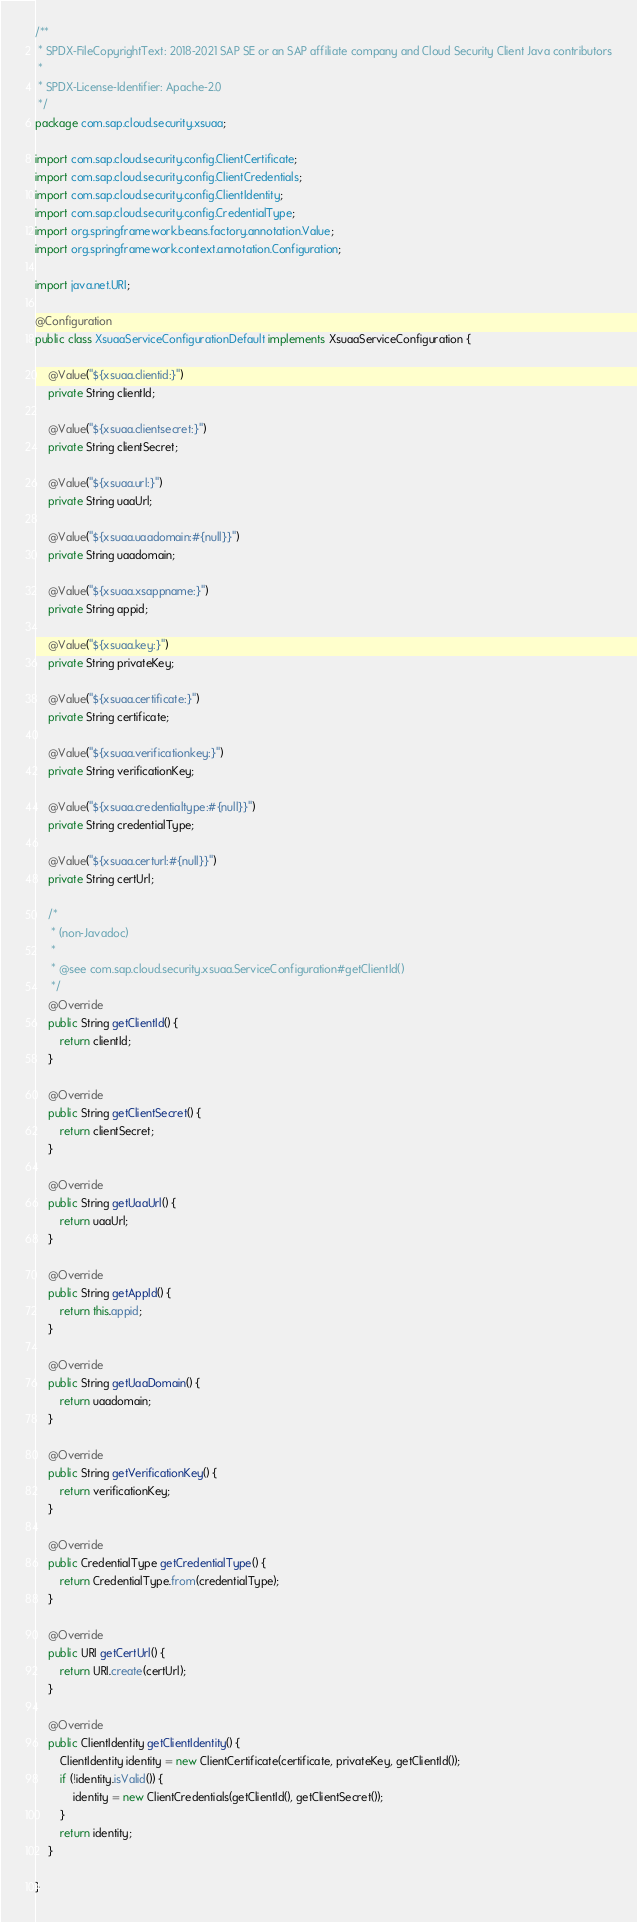Convert code to text. <code><loc_0><loc_0><loc_500><loc_500><_Java_>/**
 * SPDX-FileCopyrightText: 2018-2021 SAP SE or an SAP affiliate company and Cloud Security Client Java contributors
 *
 * SPDX-License-Identifier: Apache-2.0
 */
package com.sap.cloud.security.xsuaa;

import com.sap.cloud.security.config.ClientCertificate;
import com.sap.cloud.security.config.ClientCredentials;
import com.sap.cloud.security.config.ClientIdentity;
import com.sap.cloud.security.config.CredentialType;
import org.springframework.beans.factory.annotation.Value;
import org.springframework.context.annotation.Configuration;

import java.net.URI;

@Configuration
public class XsuaaServiceConfigurationDefault implements XsuaaServiceConfiguration {

	@Value("${xsuaa.clientid:}")
	private String clientId;

	@Value("${xsuaa.clientsecret:}")
	private String clientSecret;

	@Value("${xsuaa.url:}")
	private String uaaUrl;

	@Value("${xsuaa.uaadomain:#{null}}")
	private String uaadomain;

	@Value("${xsuaa.xsappname:}")
	private String appid;

	@Value("${xsuaa.key:}")
	private String privateKey;

	@Value("${xsuaa.certificate:}")
	private String certificate;

	@Value("${xsuaa.verificationkey:}")
	private String verificationKey;

	@Value("${xsuaa.credentialtype:#{null}}")
	private String credentialType;

	@Value("${xsuaa.certurl:#{null}}")
	private String certUrl;

	/*
	 * (non-Javadoc)
	 *
	 * @see com.sap.cloud.security.xsuaa.ServiceConfiguration#getClientId()
	 */
	@Override
	public String getClientId() {
		return clientId;
	}

	@Override
	public String getClientSecret() {
		return clientSecret;
	}

	@Override
	public String getUaaUrl() {
		return uaaUrl;
	}

	@Override
	public String getAppId() {
		return this.appid;
	}

	@Override
	public String getUaaDomain() {
		return uaadomain;
	}

	@Override
	public String getVerificationKey() {
		return verificationKey;
	}

	@Override
	public CredentialType getCredentialType() {
		return CredentialType.from(credentialType);
	}

	@Override
	public URI getCertUrl() {
		return URI.create(certUrl);
	}

	@Override
	public ClientIdentity getClientIdentity() {
		ClientIdentity identity = new ClientCertificate(certificate, privateKey, getClientId());
		if (!identity.isValid()) {
			identity = new ClientCredentials(getClientId(), getClientSecret());
		}
		return identity;
	}

}
</code> 